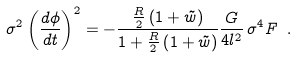Convert formula to latex. <formula><loc_0><loc_0><loc_500><loc_500>\sigma ^ { 2 } \left ( \frac { d \phi } { d t } \right ) ^ { 2 } = - \frac { \frac { R } { 2 } \left ( 1 + \tilde { w } \right ) } { 1 + \frac { R } { 2 } \left ( 1 + \tilde { w } \right ) } \frac { G } { 4 l ^ { 2 } } \, \sigma ^ { 4 } F \ .</formula> 